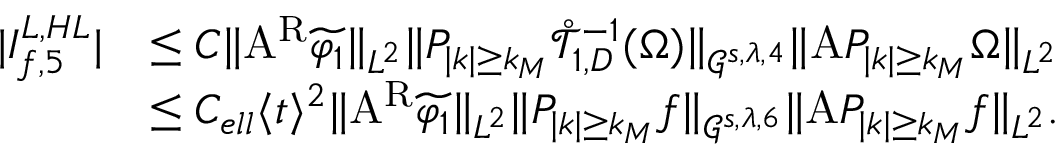<formula> <loc_0><loc_0><loc_500><loc_500>\begin{array} { r l } { | I _ { f , 5 } ^ { L , H L } | } & { \leq C \| A ^ { R } \widetilde { \varphi _ { 1 } } \| _ { L ^ { 2 } } \| P _ { | k | \geq k _ { M } } \mathring { \mathcal { T } } _ { 1 , D } ^ { - 1 } ( \Omega ) \| _ { \mathcal { G } ^ { s , \lambda , 4 } } \| A P _ { | k | \geq k _ { M } } \Omega \| _ { L ^ { 2 } } } \\ & { \leq C _ { e l l } \langle t \rangle ^ { 2 } \| A ^ { R } \widetilde { \varphi _ { 1 } } \| _ { L ^ { 2 } } \| P _ { | k | \geq k _ { M } } f \| _ { \mathcal { G } ^ { s , \lambda , 6 } } \| A P _ { | k | \geq k _ { M } } f \| _ { L ^ { 2 } } . } \end{array}</formula> 